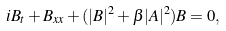<formula> <loc_0><loc_0><loc_500><loc_500>i B _ { t } + B _ { x x } + ( | B | ^ { 2 } + \beta | A | ^ { 2 } ) B = 0 ,</formula> 